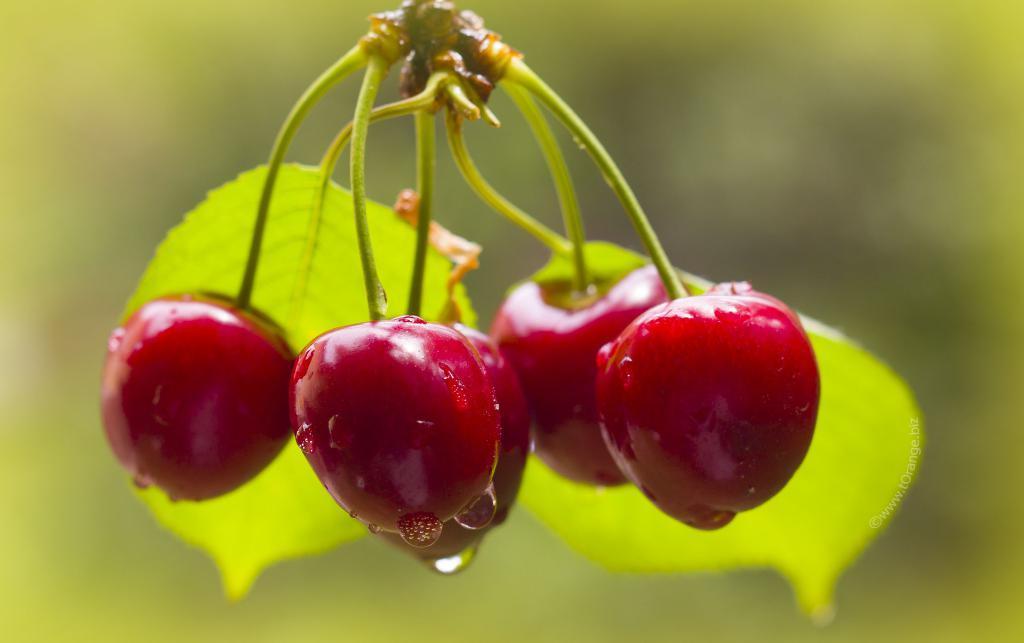Please provide a concise description of this image. In this image there are fruits, there are water drops on the fruits, there are leaves, the background of the image is blurred. 